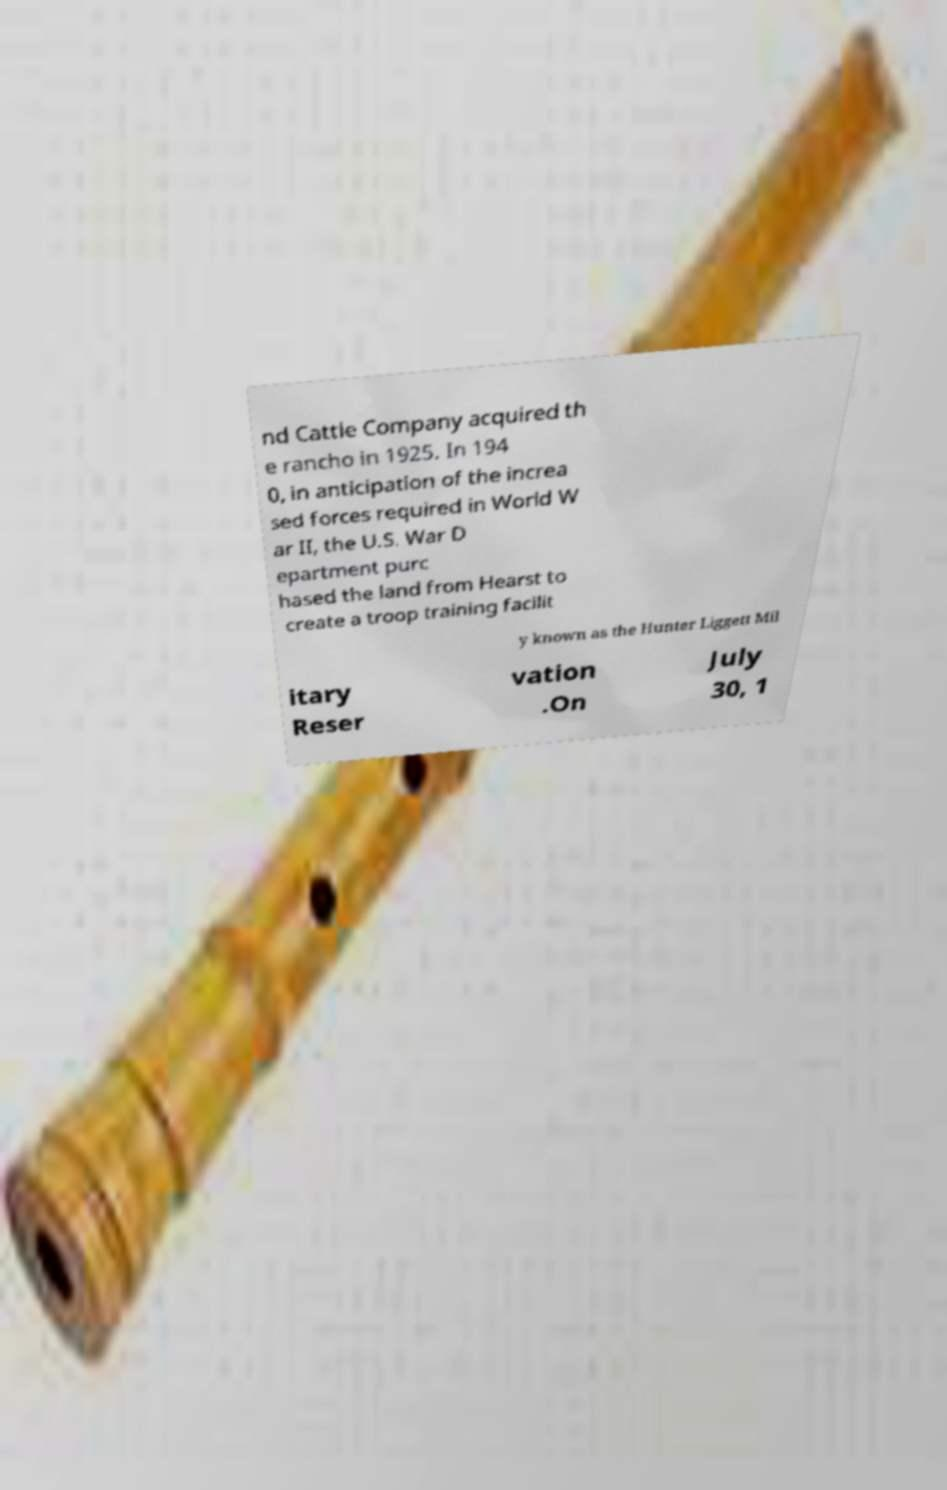Please read and relay the text visible in this image. What does it say? nd Cattle Company acquired th e rancho in 1925. In 194 0, in anticipation of the increa sed forces required in World W ar II, the U.S. War D epartment purc hased the land from Hearst to create a troop training facilit y known as the Hunter Liggett Mil itary Reser vation .On July 30, 1 